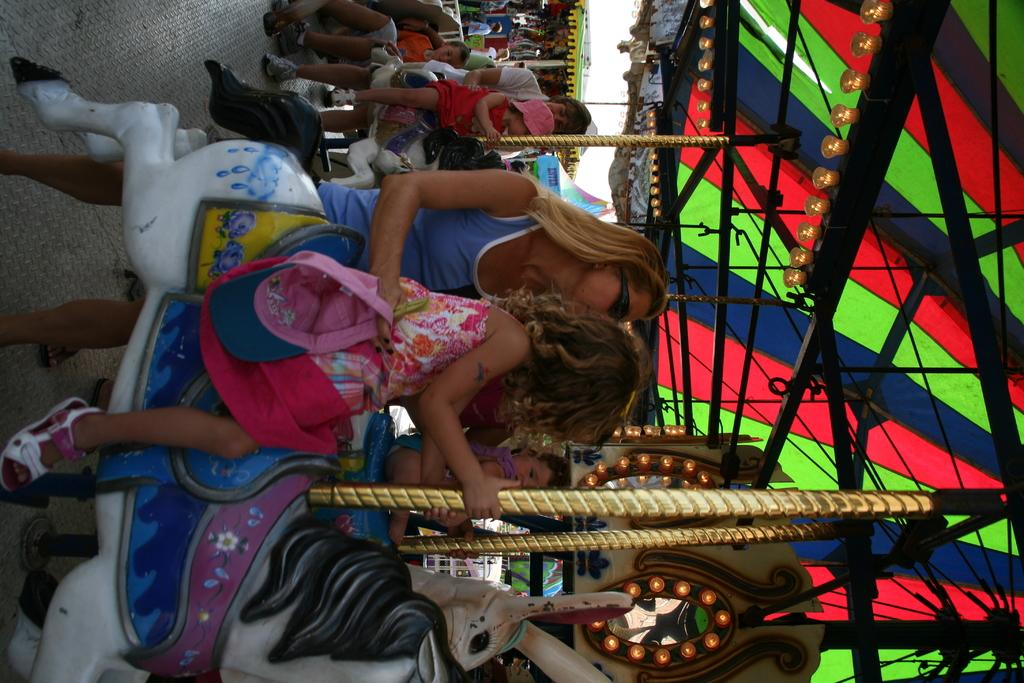How many people are in the image? There are people in the image, but the exact number is not specified. What are the people doing in the image? The people are sitting on a horse. What type of wren can be seen in the image? There is no wren present in the image; it features people sitting on a horse. Is the horse in the image located at a zoo? The location of the horse in the image is not specified, so it cannot be determined if it is at a zoo or not. 